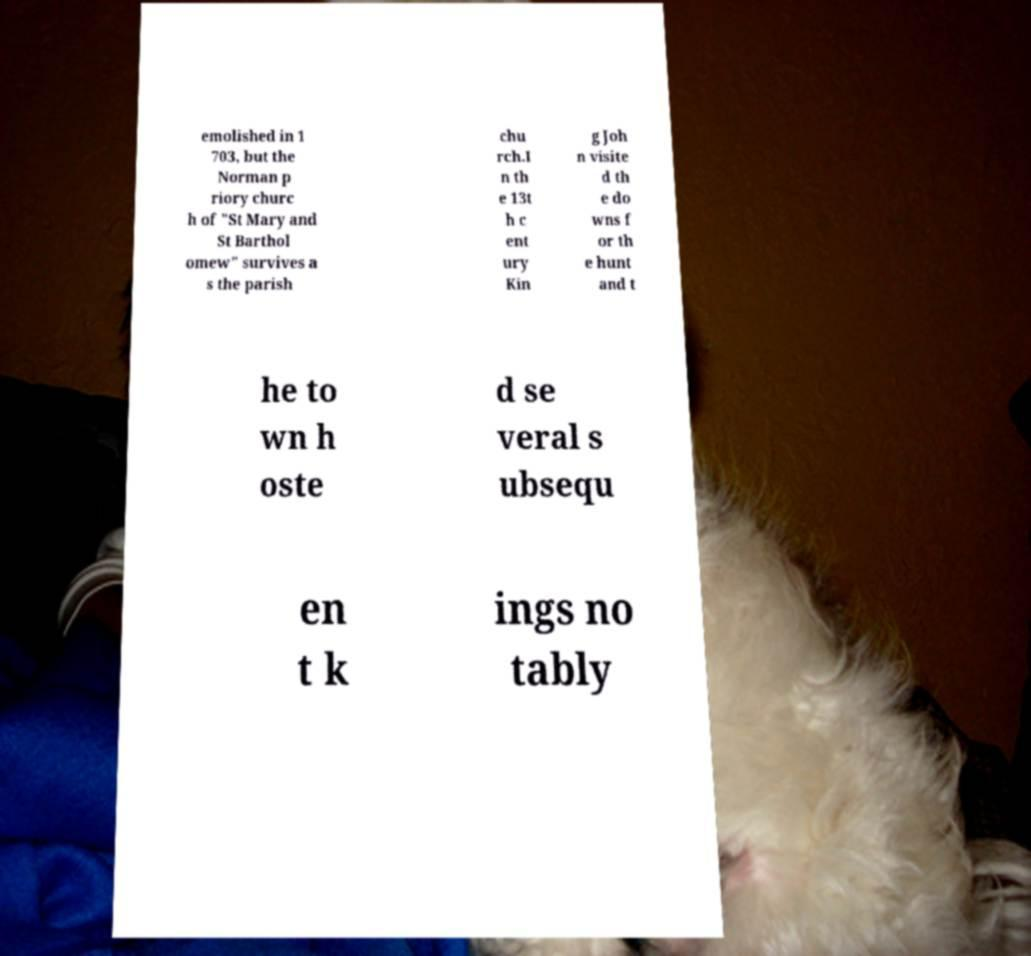Can you read and provide the text displayed in the image?This photo seems to have some interesting text. Can you extract and type it out for me? emolished in 1 703, but the Norman p riory churc h of "St Mary and St Barthol omew" survives a s the parish chu rch.I n th e 13t h c ent ury Kin g Joh n visite d th e do wns f or th e hunt and t he to wn h oste d se veral s ubsequ en t k ings no tably 